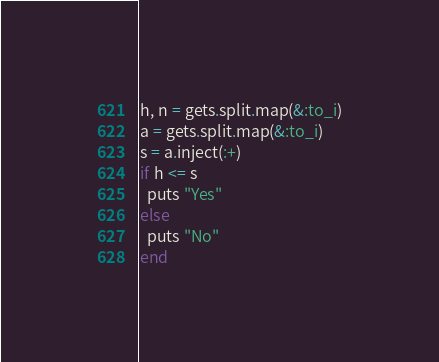Convert code to text. <code><loc_0><loc_0><loc_500><loc_500><_Ruby_>h, n = gets.split.map(&:to_i)
a = gets.split.map(&:to_i)
s = a.inject(:+)
if h <= s
  puts "Yes"
else
  puts "No"
end
</code> 